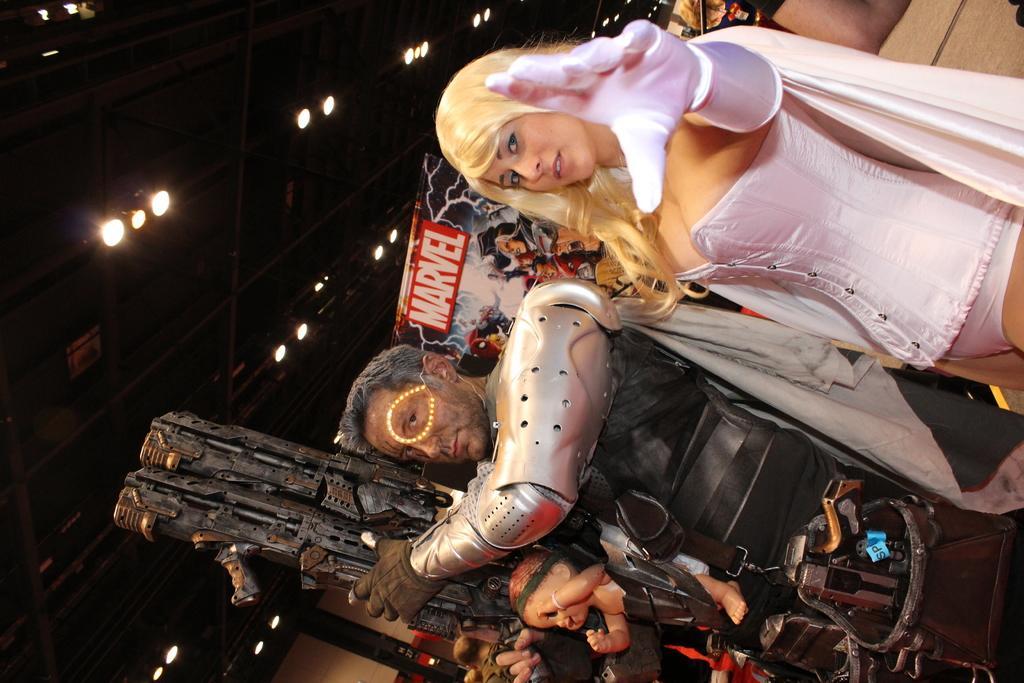Could you give a brief overview of what you see in this image? In the image we can see there are people standing and the man is holding a weapon in his hand. The man is carrying baby toy in the front and behind on the banner it's written "Marvel". There are lights on the roof top. 